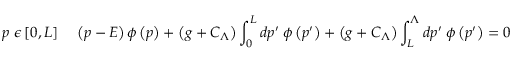<formula> <loc_0><loc_0><loc_500><loc_500>p \ \epsilon \left [ 0 , L \right ] \, \left ( p - E \right ) \phi \left ( p \right ) + \left ( g + C _ { \Lambda } \right ) \int _ { 0 } ^ { L } d p ^ { \prime } \, \phi \left ( p ^ { \prime } \right ) + \left ( g + C _ { \Lambda } \right ) \int _ { L } ^ { \Lambda } d p ^ { \prime } \, \phi \left ( p ^ { \prime } \right ) = 0</formula> 